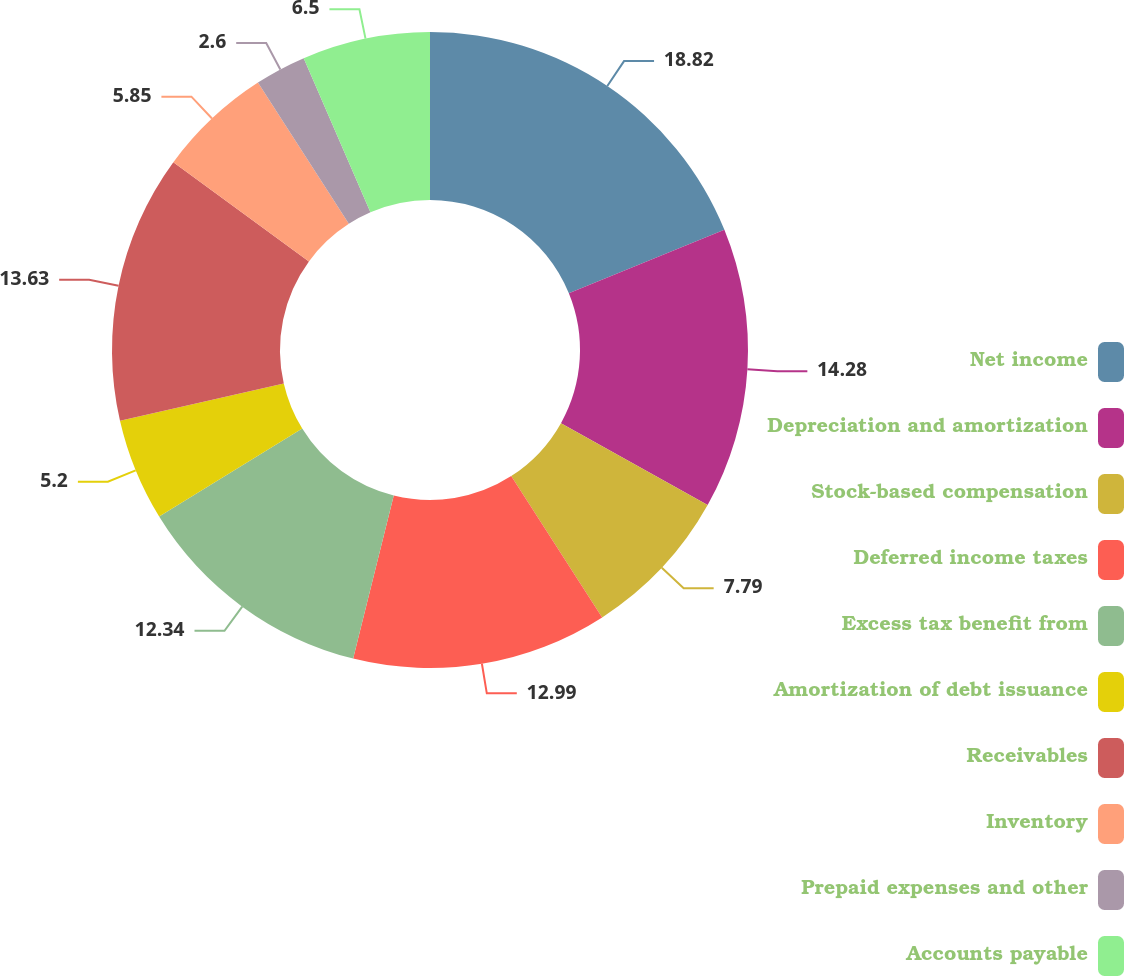<chart> <loc_0><loc_0><loc_500><loc_500><pie_chart><fcel>Net income<fcel>Depreciation and amortization<fcel>Stock-based compensation<fcel>Deferred income taxes<fcel>Excess tax benefit from<fcel>Amortization of debt issuance<fcel>Receivables<fcel>Inventory<fcel>Prepaid expenses and other<fcel>Accounts payable<nl><fcel>18.83%<fcel>14.28%<fcel>7.79%<fcel>12.99%<fcel>12.34%<fcel>5.2%<fcel>13.63%<fcel>5.85%<fcel>2.6%<fcel>6.5%<nl></chart> 